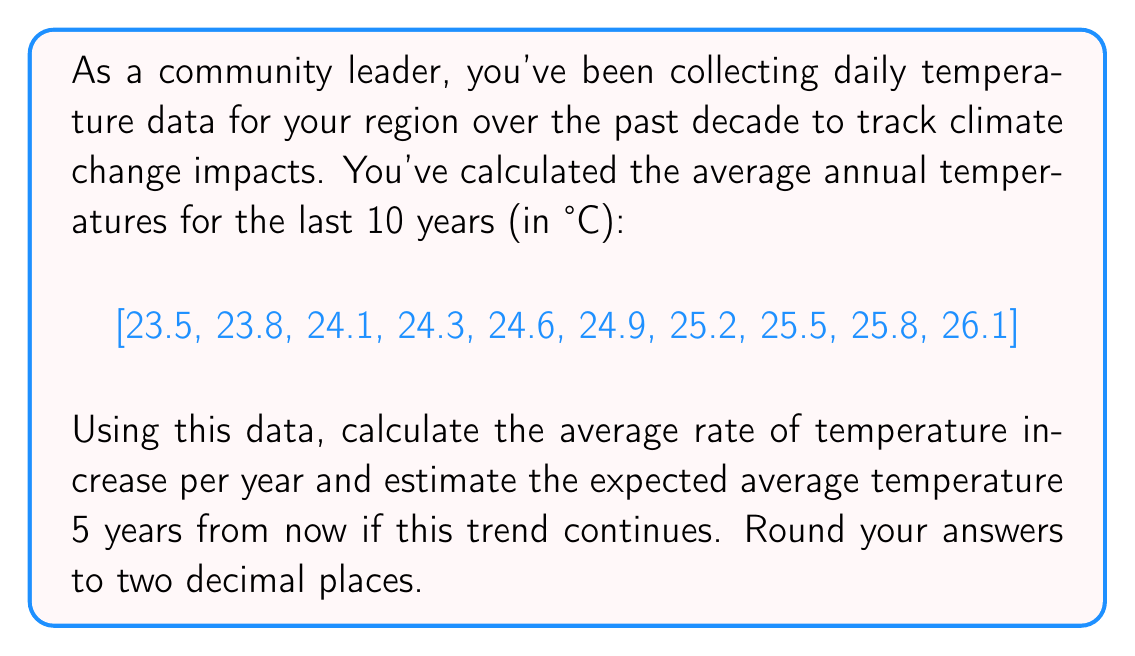Could you help me with this problem? To solve this problem, we'll use linear regression techniques for time series analysis.

1. First, let's calculate the slope (rate of temperature increase per year):

   We can use the formula for the slope of a linear regression line:
   
   $$ m = \frac{n\sum{xy} - \sum{x}\sum{y}}{n\sum{x^2} - (\sum{x})^2} $$

   Where:
   $x$ represents the year (0 to 9)
   $y$ represents the temperature
   $n$ is the number of data points (10)

   Calculating the necessary sums:
   $\sum{x} = 45$
   $\sum{y} = 247.8$
   $\sum{xy} = 1260.9$
   $\sum{x^2} = 285$

   Plugging into the formula:
   
   $$ m = \frac{10(1260.9) - 45(247.8)}{10(285) - 45^2} = 0.29 $$

2. Now that we have the slope, we can use it to predict the temperature in 5 years:

   We'll use the point-slope form of a line: $y - y_1 = m(x - x_1)$
   
   Where:
   $(x_1, y_1)$ is the last data point (9, 26.1)
   $m$ is our calculated slope (0.29)
   $x$ is 14 (5 years from the last data point)

   $y - 26.1 = 0.29(14 - 9)$
   $y - 26.1 = 0.29(5)$
   $y - 26.1 = 1.45$
   $y = 27.55$

Therefore, the average rate of temperature increase per year is 0.29°C, and the estimated average temperature 5 years from now is 27.55°C.
Answer: Average rate of temperature increase per year: 0.29°C
Estimated average temperature in 5 years: 27.55°C 